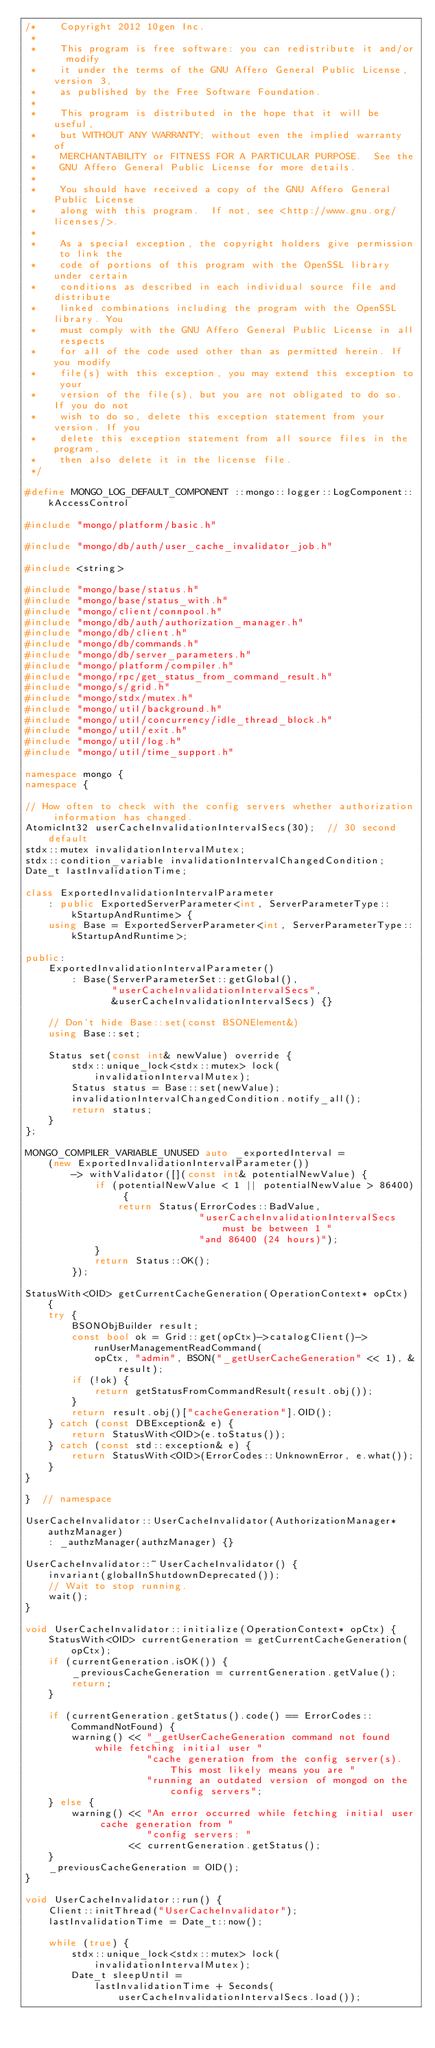<code> <loc_0><loc_0><loc_500><loc_500><_C++_>/*    Copyright 2012 10gen Inc.
 *
 *    This program is free software: you can redistribute it and/or  modify
 *    it under the terms of the GNU Affero General Public License, version 3,
 *    as published by the Free Software Foundation.
 *
 *    This program is distributed in the hope that it will be useful,
 *    but WITHOUT ANY WARRANTY; without even the implied warranty of
 *    MERCHANTABILITY or FITNESS FOR A PARTICULAR PURPOSE.  See the
 *    GNU Affero General Public License for more details.
 *
 *    You should have received a copy of the GNU Affero General Public License
 *    along with this program.  If not, see <http://www.gnu.org/licenses/>.
 *
 *    As a special exception, the copyright holders give permission to link the
 *    code of portions of this program with the OpenSSL library under certain
 *    conditions as described in each individual source file and distribute
 *    linked combinations including the program with the OpenSSL library. You
 *    must comply with the GNU Affero General Public License in all respects
 *    for all of the code used other than as permitted herein. If you modify
 *    file(s) with this exception, you may extend this exception to your
 *    version of the file(s), but you are not obligated to do so. If you do not
 *    wish to do so, delete this exception statement from your version. If you
 *    delete this exception statement from all source files in the program,
 *    then also delete it in the license file.
 */

#define MONGO_LOG_DEFAULT_COMPONENT ::mongo::logger::LogComponent::kAccessControl

#include "mongo/platform/basic.h"

#include "mongo/db/auth/user_cache_invalidator_job.h"

#include <string>

#include "mongo/base/status.h"
#include "mongo/base/status_with.h"
#include "mongo/client/connpool.h"
#include "mongo/db/auth/authorization_manager.h"
#include "mongo/db/client.h"
#include "mongo/db/commands.h"
#include "mongo/db/server_parameters.h"
#include "mongo/platform/compiler.h"
#include "mongo/rpc/get_status_from_command_result.h"
#include "mongo/s/grid.h"
#include "mongo/stdx/mutex.h"
#include "mongo/util/background.h"
#include "mongo/util/concurrency/idle_thread_block.h"
#include "mongo/util/exit.h"
#include "mongo/util/log.h"
#include "mongo/util/time_support.h"

namespace mongo {
namespace {

// How often to check with the config servers whether authorization information has changed.
AtomicInt32 userCacheInvalidationIntervalSecs(30);  // 30 second default
stdx::mutex invalidationIntervalMutex;
stdx::condition_variable invalidationIntervalChangedCondition;
Date_t lastInvalidationTime;

class ExportedInvalidationIntervalParameter
    : public ExportedServerParameter<int, ServerParameterType::kStartupAndRuntime> {
    using Base = ExportedServerParameter<int, ServerParameterType::kStartupAndRuntime>;

public:
    ExportedInvalidationIntervalParameter()
        : Base(ServerParameterSet::getGlobal(),
               "userCacheInvalidationIntervalSecs",
               &userCacheInvalidationIntervalSecs) {}

    // Don't hide Base::set(const BSONElement&)
    using Base::set;

    Status set(const int& newValue) override {
        stdx::unique_lock<stdx::mutex> lock(invalidationIntervalMutex);
        Status status = Base::set(newValue);
        invalidationIntervalChangedCondition.notify_all();
        return status;
    }
};

MONGO_COMPILER_VARIABLE_UNUSED auto _exportedInterval =
    (new ExportedInvalidationIntervalParameter())
        -> withValidator([](const int& potentialNewValue) {
            if (potentialNewValue < 1 || potentialNewValue > 86400) {
                return Status(ErrorCodes::BadValue,
                              "userCacheInvalidationIntervalSecs must be between 1 "
                              "and 86400 (24 hours)");
            }
            return Status::OK();
        });

StatusWith<OID> getCurrentCacheGeneration(OperationContext* opCtx) {
    try {
        BSONObjBuilder result;
        const bool ok = Grid::get(opCtx)->catalogClient()->runUserManagementReadCommand(
            opCtx, "admin", BSON("_getUserCacheGeneration" << 1), &result);
        if (!ok) {
            return getStatusFromCommandResult(result.obj());
        }
        return result.obj()["cacheGeneration"].OID();
    } catch (const DBException& e) {
        return StatusWith<OID>(e.toStatus());
    } catch (const std::exception& e) {
        return StatusWith<OID>(ErrorCodes::UnknownError, e.what());
    }
}

}  // namespace

UserCacheInvalidator::UserCacheInvalidator(AuthorizationManager* authzManager)
    : _authzManager(authzManager) {}

UserCacheInvalidator::~UserCacheInvalidator() {
    invariant(globalInShutdownDeprecated());
    // Wait to stop running.
    wait();
}

void UserCacheInvalidator::initialize(OperationContext* opCtx) {
    StatusWith<OID> currentGeneration = getCurrentCacheGeneration(opCtx);
    if (currentGeneration.isOK()) {
        _previousCacheGeneration = currentGeneration.getValue();
        return;
    }

    if (currentGeneration.getStatus().code() == ErrorCodes::CommandNotFound) {
        warning() << "_getUserCacheGeneration command not found while fetching initial user "
                     "cache generation from the config server(s).  This most likely means you are "
                     "running an outdated version of mongod on the config servers";
    } else {
        warning() << "An error occurred while fetching initial user cache generation from "
                     "config servers: "
                  << currentGeneration.getStatus();
    }
    _previousCacheGeneration = OID();
}

void UserCacheInvalidator::run() {
    Client::initThread("UserCacheInvalidator");
    lastInvalidationTime = Date_t::now();

    while (true) {
        stdx::unique_lock<stdx::mutex> lock(invalidationIntervalMutex);
        Date_t sleepUntil =
            lastInvalidationTime + Seconds(userCacheInvalidationIntervalSecs.load());</code> 